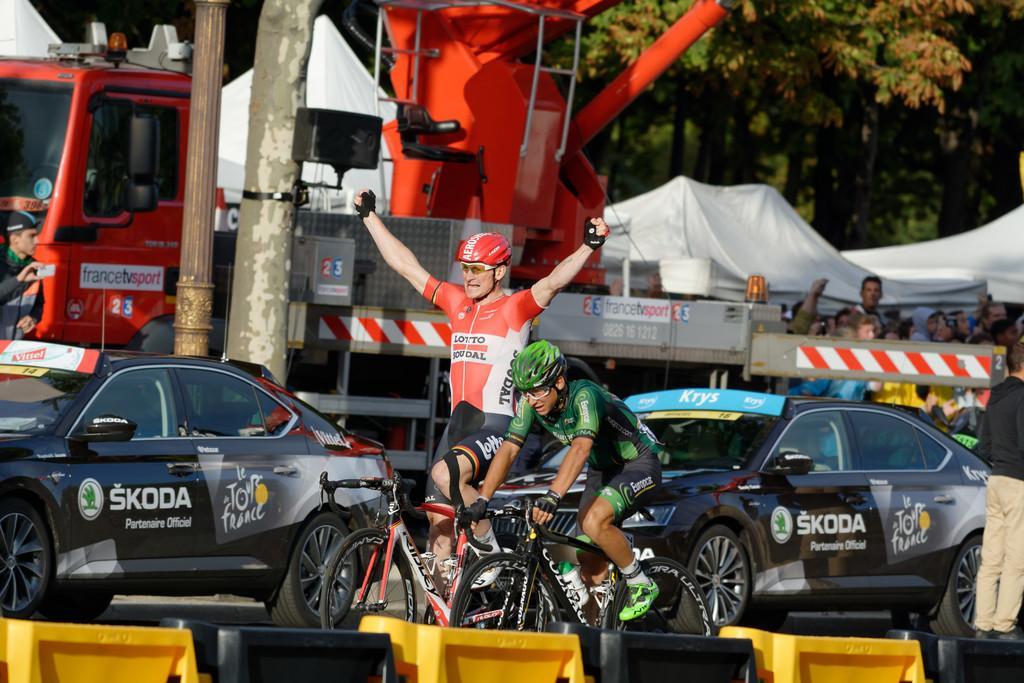Describe this image in one or two sentences. As we can see in the image there are few people, bicycles, cars, truck and there are trees. 